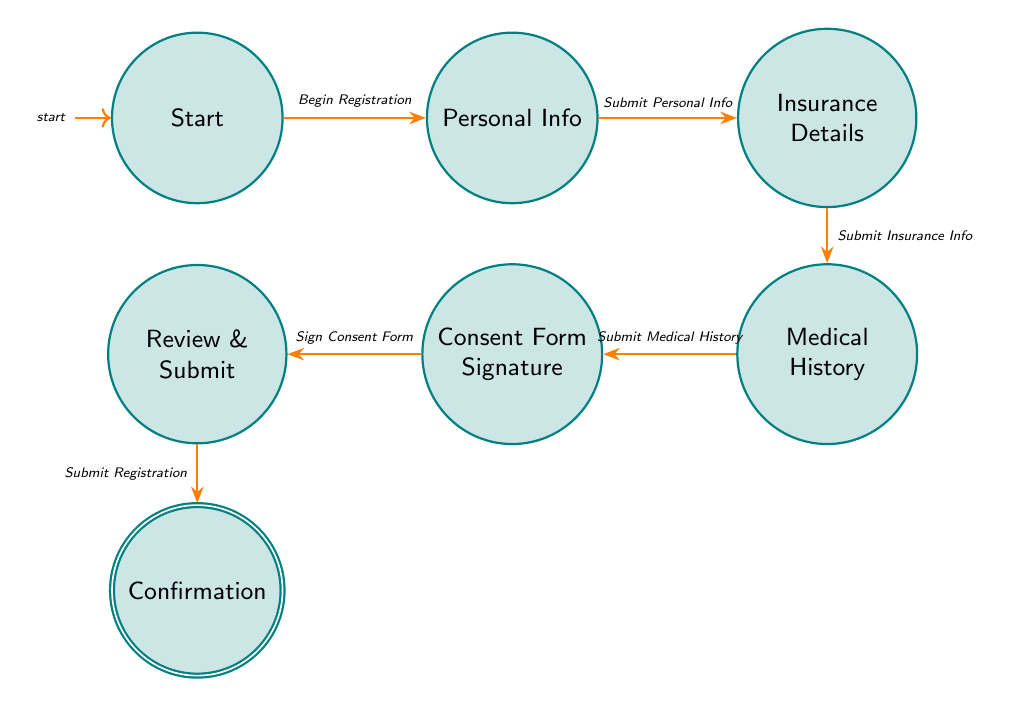What is the first state in the registration process? The diagram indicates that the first state is 'Start', which is where the patient begins the registration process.
Answer: Start How many total states are present in the diagram? By counting the states in the diagram, we find there are seven: Start, Personal Info, Insurance Details, Medical History, Consent Form Signature, Review & Submit, and Confirmation.
Answer: Seven What action leads to the 'Insurance Details' state? The transition from 'Personal Info' to 'Insurance Details' happens through the action 'Submit Personal Info', which is the next step after entering personal information.
Answer: Submit Personal Info What is the last step before reaching the 'Confirmation' state? The last step prior to 'Confirmation' is 'Submit Registration', which is part of the review and final submission process before confirming the registration.
Answer: Submit Registration Which state follows 'Medical History'? The state that directly follows 'Medical History' is 'Consent Form Signature', indicating that after declaring medical history, the patient moves to the consent phase.
Answer: Consent Form Signature How many transitions are there in total? The diagram has six transitions connecting all the states defined in the flow of the registration process.
Answer: Six What action occurs after 'Submit Insurance Info'? After 'Submit Insurance Info', the patient transitions to the 'Medical History' state, indicating that providing insurance information leads to a declaration of medical history.
Answer: Submit Medical History What is the purpose of the state 'Consent Form Signature'? The purpose of the 'Consent Form Signature' state is for the patient to sign the consent form for treatment and data use, which is an essential step in the registration process.
Answer: Sign Consent Form 